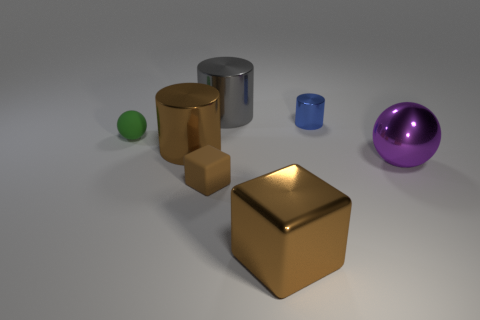Subtract all big brown cylinders. How many cylinders are left? 2 Subtract all brown cylinders. How many cylinders are left? 2 Add 3 tiny brown objects. How many objects exist? 10 Subtract 3 cylinders. How many cylinders are left? 0 Subtract all blocks. How many objects are left? 5 Subtract all brown cylinders. Subtract all green cubes. How many cylinders are left? 2 Subtract all blue blocks. How many gray cylinders are left? 1 Subtract all rubber objects. Subtract all large gray cylinders. How many objects are left? 4 Add 1 tiny blue metal cylinders. How many tiny blue metal cylinders are left? 2 Add 5 tiny blue objects. How many tiny blue objects exist? 6 